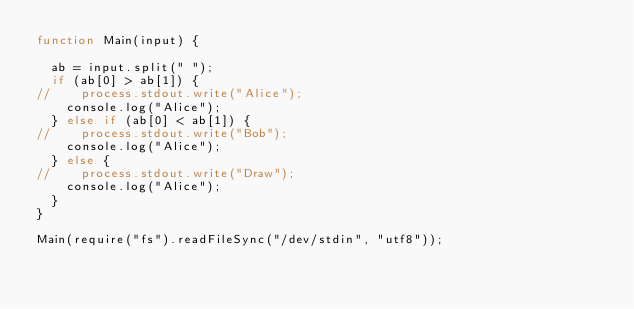<code> <loc_0><loc_0><loc_500><loc_500><_JavaScript_>function Main(input) {

  ab = input.split(" ");
  if (ab[0] > ab[1]) {
//    process.stdout.write("Alice");
    console.log("Alice");
  } else if (ab[0] < ab[1]) {
//    process.stdout.write("Bob");
    console.log("Alice");
  } else {
//    process.stdout.write("Draw");
    console.log("Alice");
  }
}

Main(require("fs").readFileSync("/dev/stdin", "utf8"));</code> 